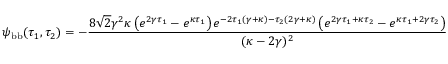Convert formula to latex. <formula><loc_0><loc_0><loc_500><loc_500>\psi _ { b b } ( \tau _ { 1 } , \tau _ { 2 } ) = - \frac { 8 \sqrt { 2 } \gamma ^ { 2 } \kappa \left ( e ^ { 2 \gamma \tau _ { 1 } } - e ^ { \kappa \tau _ { 1 } } \right ) e ^ { - 2 \tau _ { 1 } ( \gamma + \kappa ) - \tau _ { 2 } ( 2 \gamma + \kappa ) } \left ( e ^ { 2 \gamma \tau _ { 1 } + \kappa \tau _ { 2 } } - e ^ { \kappa \tau _ { 1 } + 2 \gamma \tau _ { 2 } } \right ) } { ( \kappa - 2 \gamma ) ^ { 2 } }</formula> 